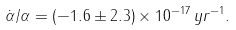Convert formula to latex. <formula><loc_0><loc_0><loc_500><loc_500>\ \dot { \alpha } / \alpha = ( - 1 . 6 \pm 2 . 3 ) \times 1 0 ^ { - 1 7 } \, y r ^ { - 1 } . \</formula> 